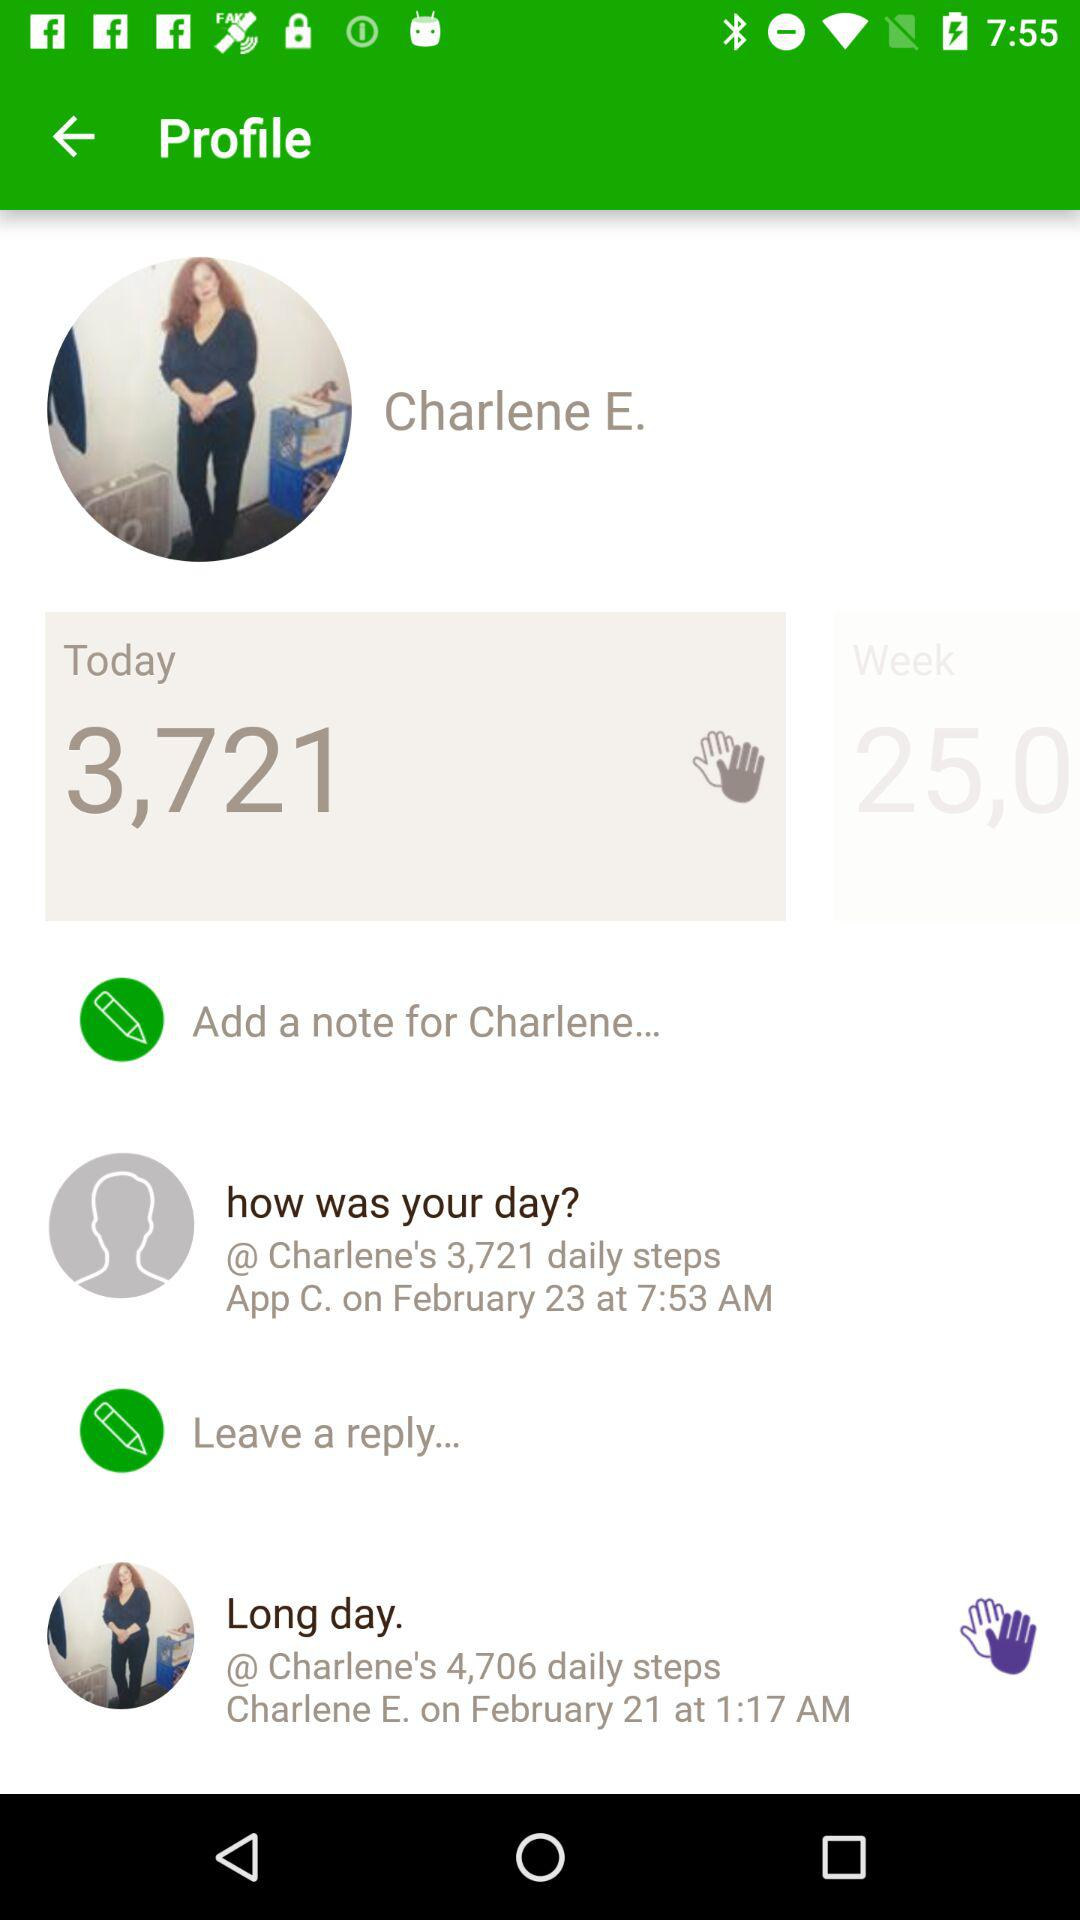How many daily steps are there for "Long day"? There are 4,706 daily steps. 